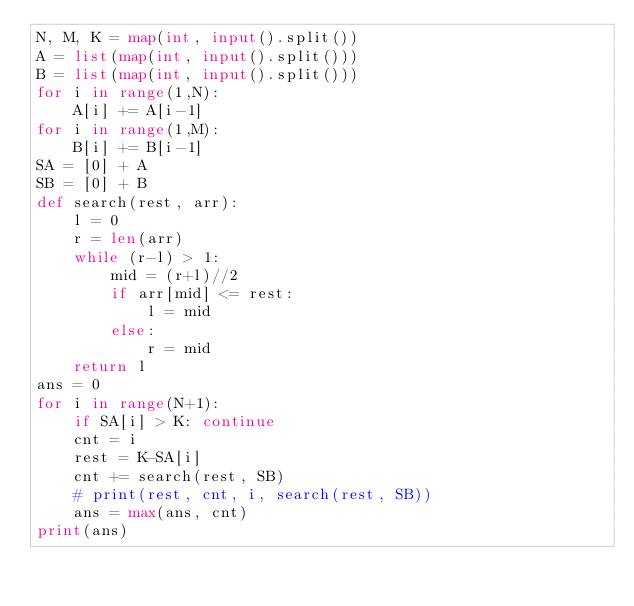<code> <loc_0><loc_0><loc_500><loc_500><_Python_>N, M, K = map(int, input().split())
A = list(map(int, input().split()))
B = list(map(int, input().split()))
for i in range(1,N):
    A[i] += A[i-1]
for i in range(1,M):
    B[i] += B[i-1]
SA = [0] + A
SB = [0] + B
def search(rest, arr):
    l = 0
    r = len(arr)
    while (r-l) > 1:
        mid = (r+l)//2
        if arr[mid] <= rest:
            l = mid
        else:
            r = mid
    return l
ans = 0
for i in range(N+1):
    if SA[i] > K: continue
    cnt = i
    rest = K-SA[i]
    cnt += search(rest, SB)
    # print(rest, cnt, i, search(rest, SB))
    ans = max(ans, cnt)
print(ans)
</code> 